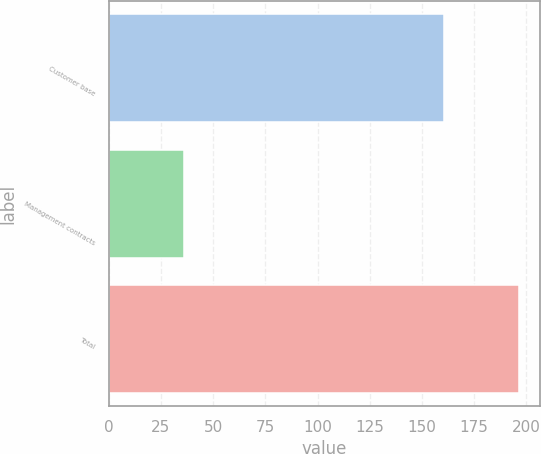Convert chart. <chart><loc_0><loc_0><loc_500><loc_500><bar_chart><fcel>Customer base<fcel>Management contracts<fcel>Total<nl><fcel>160.3<fcel>36.2<fcel>196.5<nl></chart> 